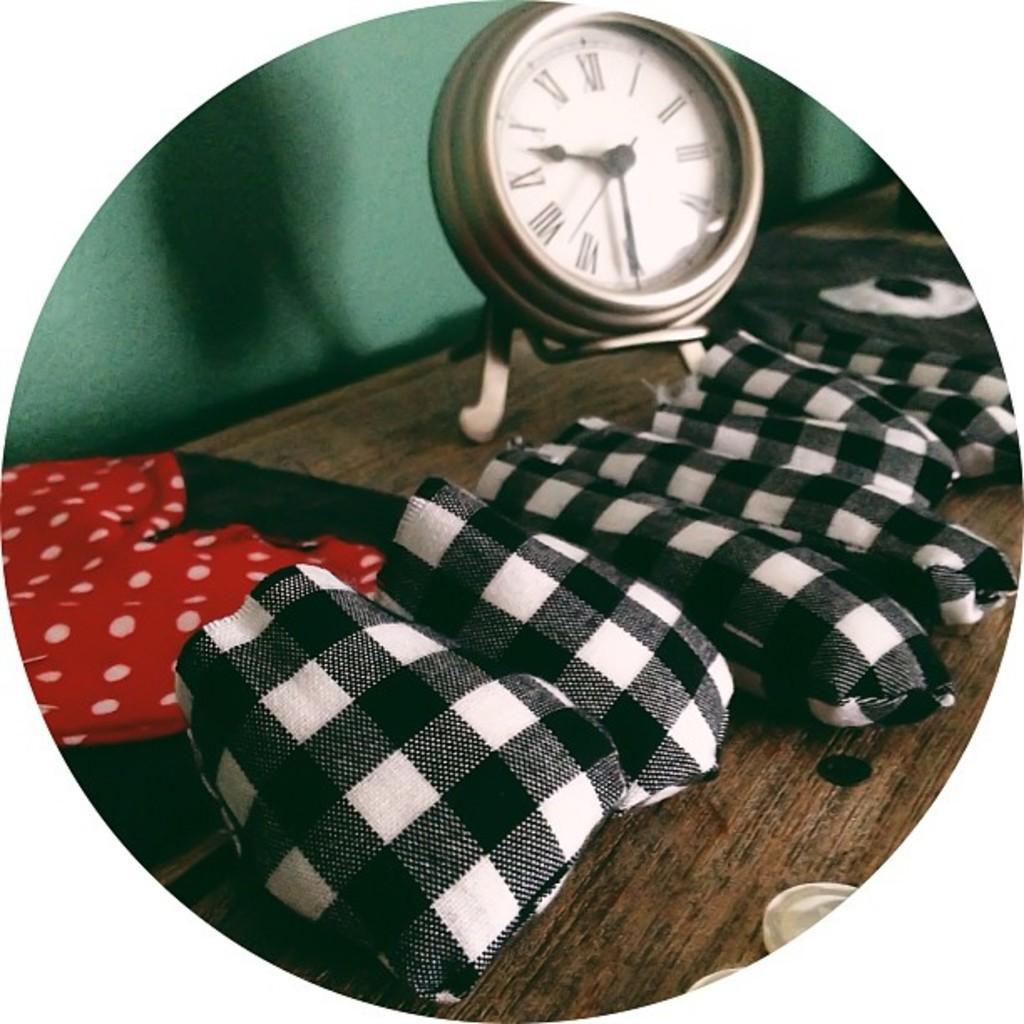Please provide a concise description of this image. This is an edited image with the borders. In the center there is a wooden table on the top of which handkerchiefs and a clock and some other items are placed. In the background there is a green color wall. 